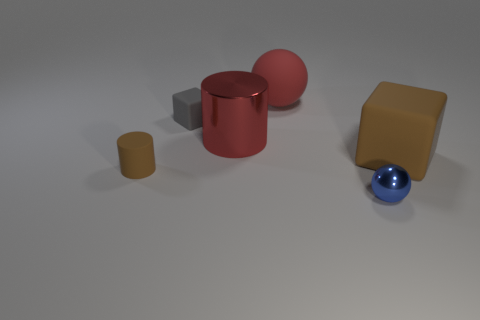What number of red balls have the same material as the blue ball?
Provide a short and direct response. 0. How many things are either blue things or small red metallic balls?
Offer a very short reply. 1. Are any brown cubes visible?
Keep it short and to the point. Yes. What is the red object in front of the sphere that is behind the brown rubber object that is on the left side of the tiny gray rubber object made of?
Your answer should be compact. Metal. Is the number of big matte cubes that are on the left side of the tiny rubber cube less than the number of big matte spheres?
Provide a short and direct response. Yes. There is a blue sphere that is the same size as the gray thing; what is its material?
Your answer should be compact. Metal. How big is the thing that is both to the right of the big red matte sphere and behind the small brown rubber object?
Keep it short and to the point. Large. What size is the matte object that is the same shape as the big red metallic thing?
Provide a succinct answer. Small. How many things are either cubes or objects that are on the right side of the gray thing?
Offer a terse response. 5. The small brown rubber object has what shape?
Your response must be concise. Cylinder. 